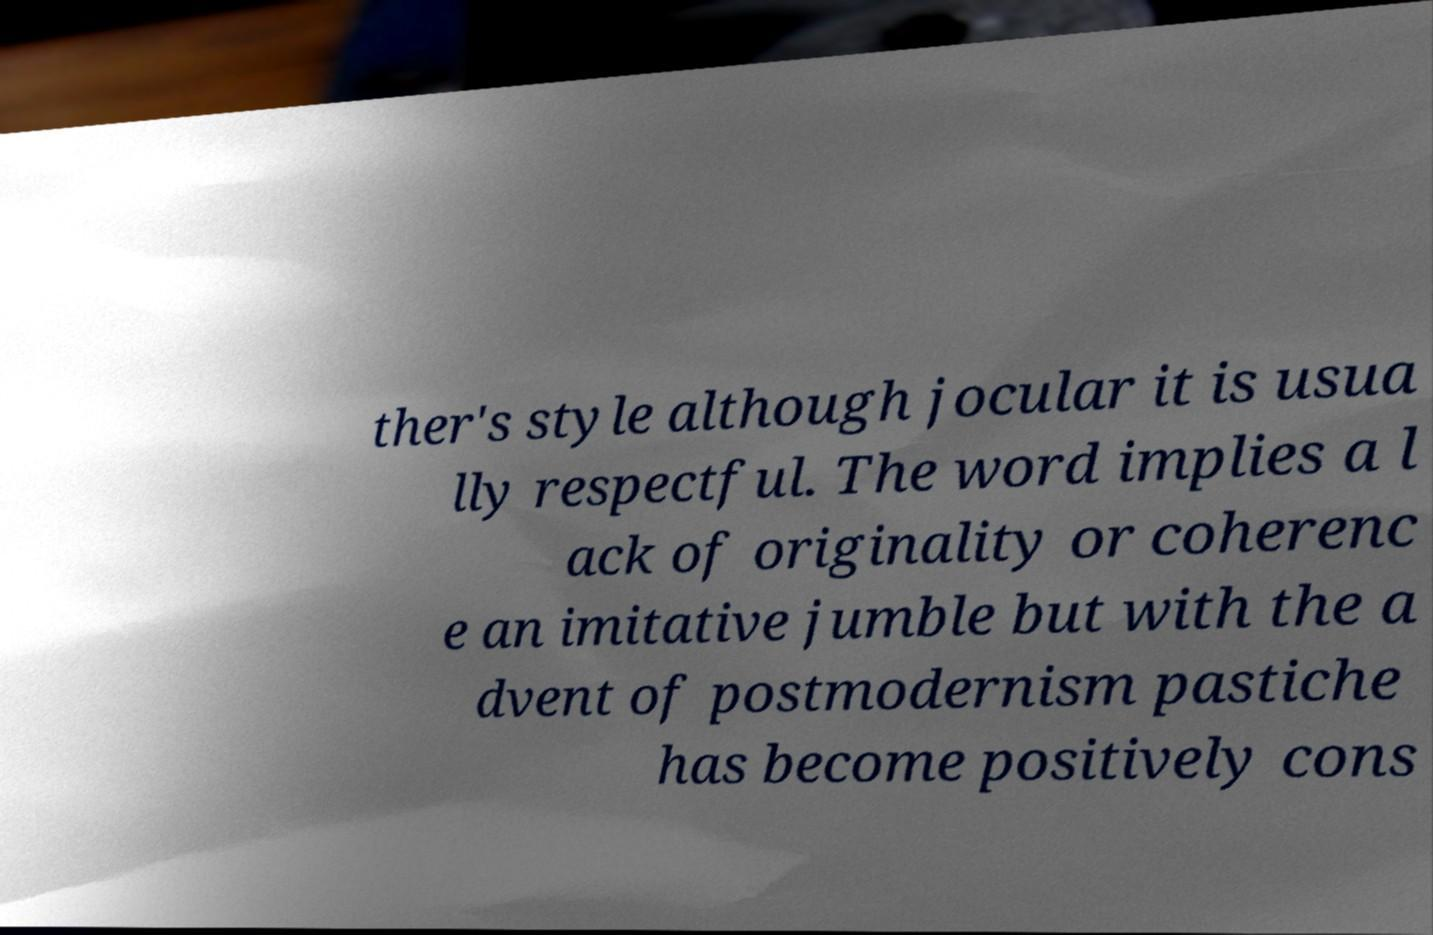There's text embedded in this image that I need extracted. Can you transcribe it verbatim? ther's style although jocular it is usua lly respectful. The word implies a l ack of originality or coherenc e an imitative jumble but with the a dvent of postmodernism pastiche has become positively cons 